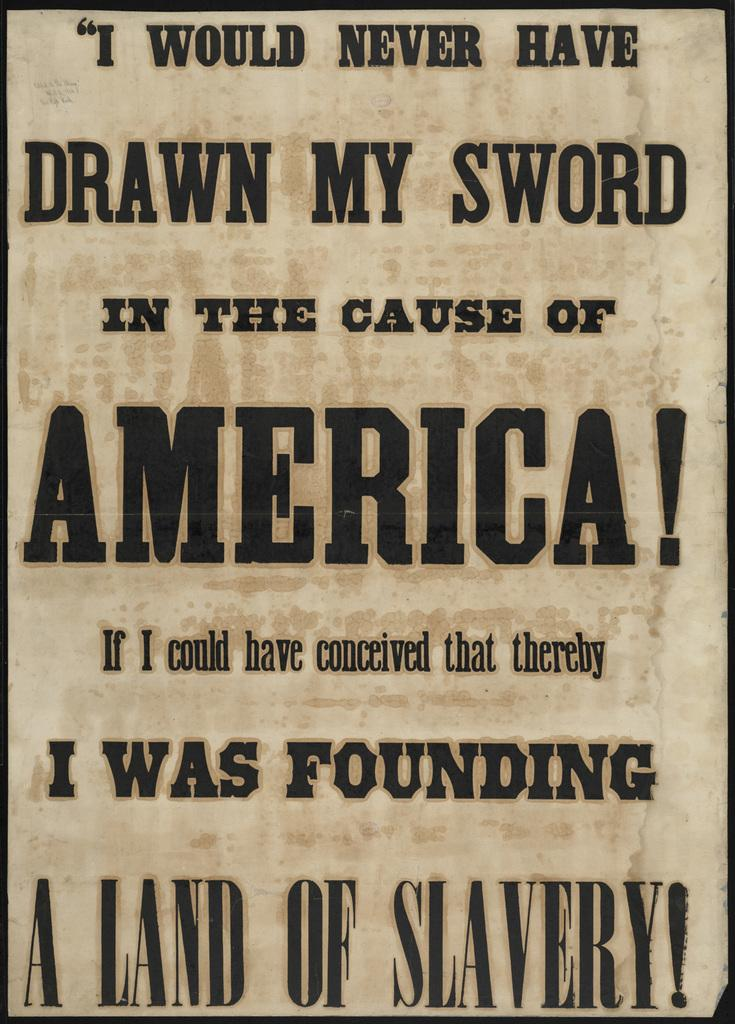<image>
Offer a succinct explanation of the picture presented. Would never have drawn my sword in the cause of America sign. 